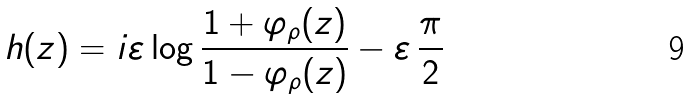Convert formula to latex. <formula><loc_0><loc_0><loc_500><loc_500>h ( z ) = i \varepsilon \log \frac { 1 + \varphi _ { \rho } ( z ) } { 1 - \varphi _ { \rho } ( z ) } - \varepsilon \, \frac { \pi } { 2 }</formula> 